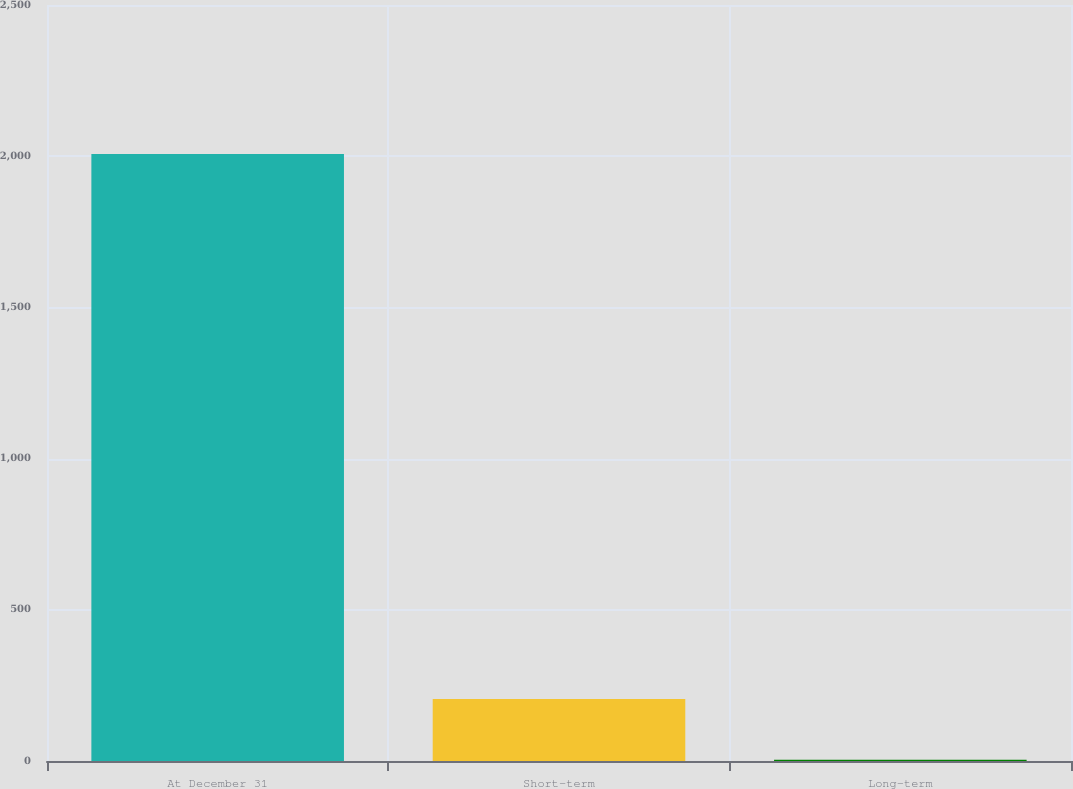Convert chart. <chart><loc_0><loc_0><loc_500><loc_500><bar_chart><fcel>At December 31<fcel>Short-term<fcel>Long-term<nl><fcel>2007<fcel>204.73<fcel>4.48<nl></chart> 